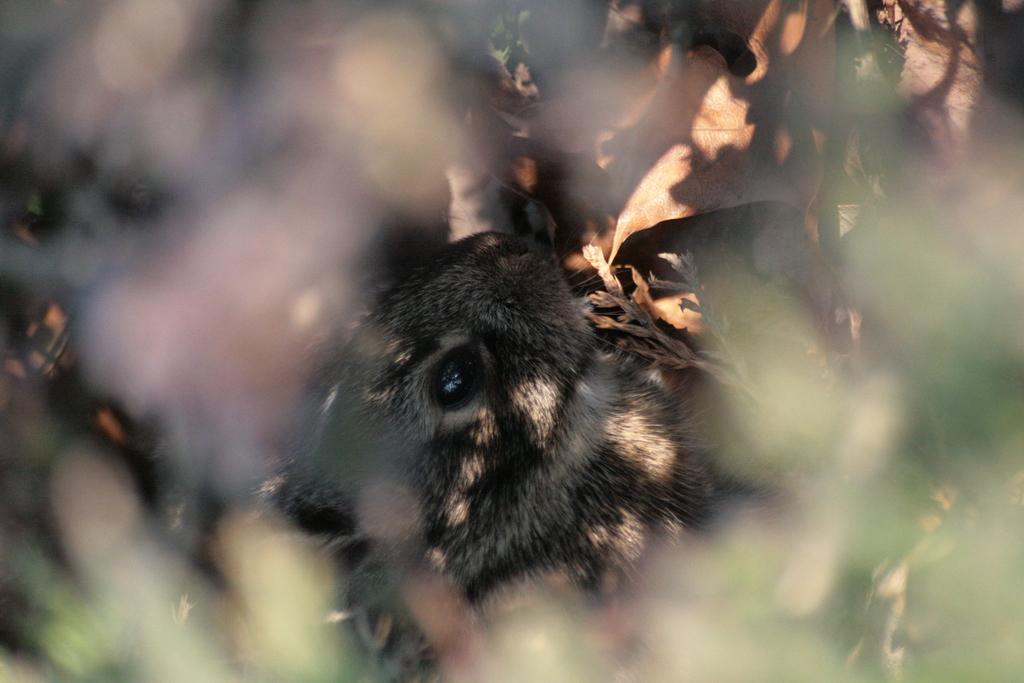What type of living creature is present in the image? There is an animal in the image. What can be seen in the background of the image? There are trees in the image. What type of table is visible in the image? There is no table present in the image. How far is the range of the animal in the image? The range of the animal cannot be determined from the image, as it does not provide information about the animal's movement or capabilities. 